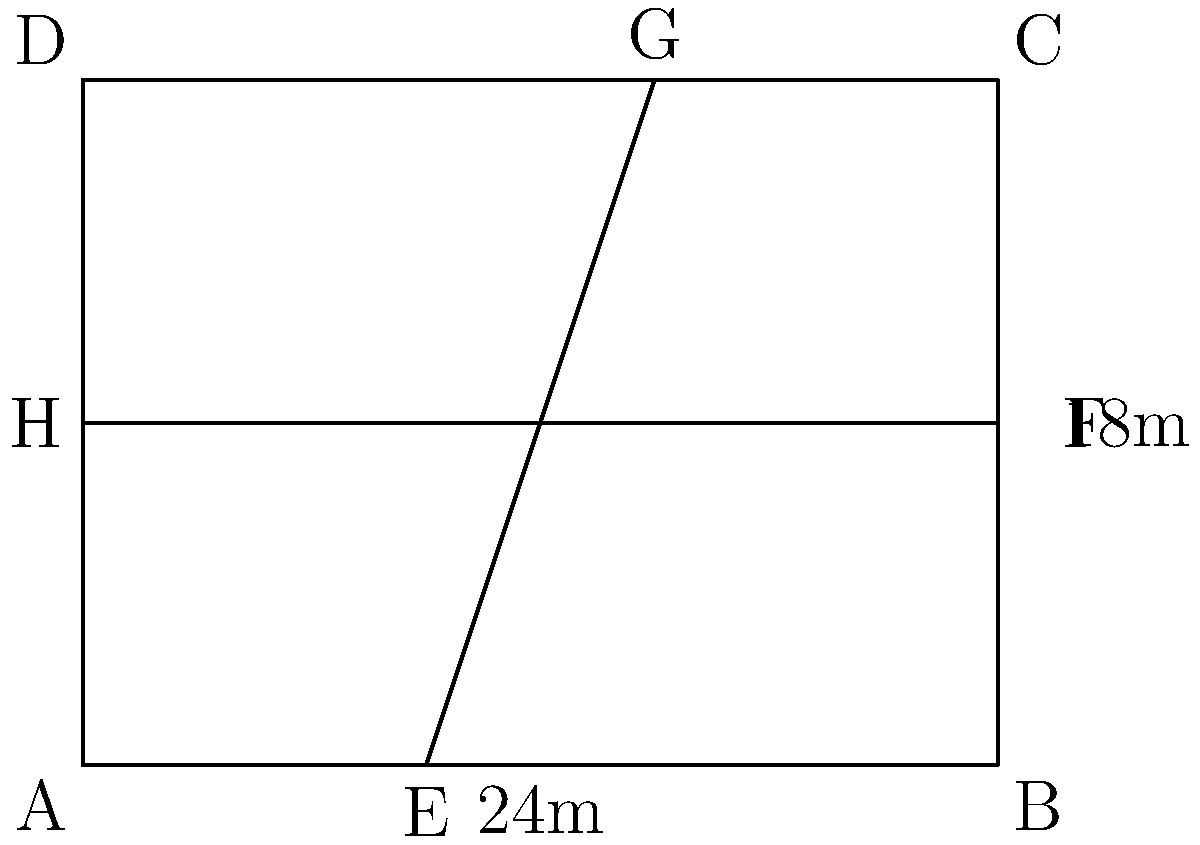A rectangular sports merchandise store measures 24m by 18m. To maximize customer flow and revenue, you decide to divide the store into four sections using two diagonal aisles. If the aisles intersect at the center of the store, what is the total floor area (in square meters) of the largest section created by this layout? To solve this problem, let's follow these steps:

1) First, we need to identify that the store is divided into four triangular sections by the diagonal aisles.

2) The center of the store, where the aisles intersect, divides each side of the rectangle in half. So, we have:
   - Width halves: 12m each
   - Length halves: 9m each

3) Each section is a right-angled triangle. The largest sections will be the ones at the corners with the 90-degree angles of the store.

4) For these largest sections, we know two sides of the right-angled triangle:
   - Base = 12m
   - Height = 9m

5) To calculate the area of a triangle, we use the formula:
   $$ Area = \frac{1}{2} \times base \times height $$

6) Plugging in our values:
   $$ Area = \frac{1}{2} \times 12 \times 9 = 54 \text{ m}^2 $$

Therefore, the area of the largest section is 54 square meters.
Answer: 54 m² 